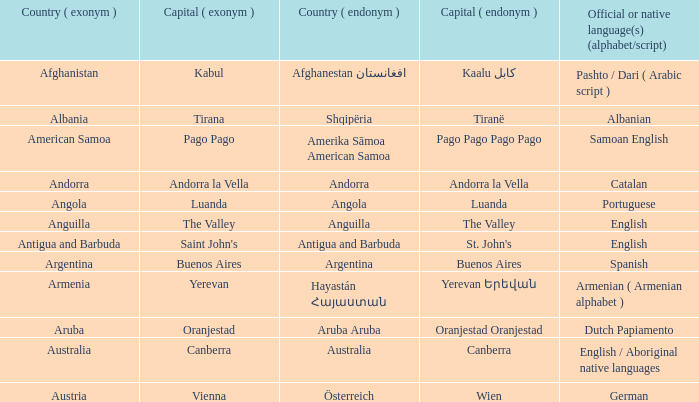What is the English name given to the city of St. John's? Saint John's. 